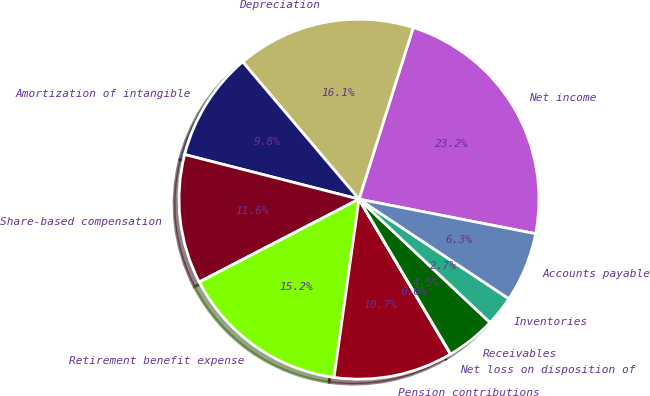Convert chart to OTSL. <chart><loc_0><loc_0><loc_500><loc_500><pie_chart><fcel>Net income<fcel>Depreciation<fcel>Amortization of intangible<fcel>Share-based compensation<fcel>Retirement benefit expense<fcel>Pension contributions<fcel>Net loss on disposition of<fcel>Receivables<fcel>Inventories<fcel>Accounts payable<nl><fcel>23.2%<fcel>16.06%<fcel>9.82%<fcel>11.6%<fcel>15.17%<fcel>10.71%<fcel>0.01%<fcel>4.47%<fcel>2.69%<fcel>6.26%<nl></chart> 